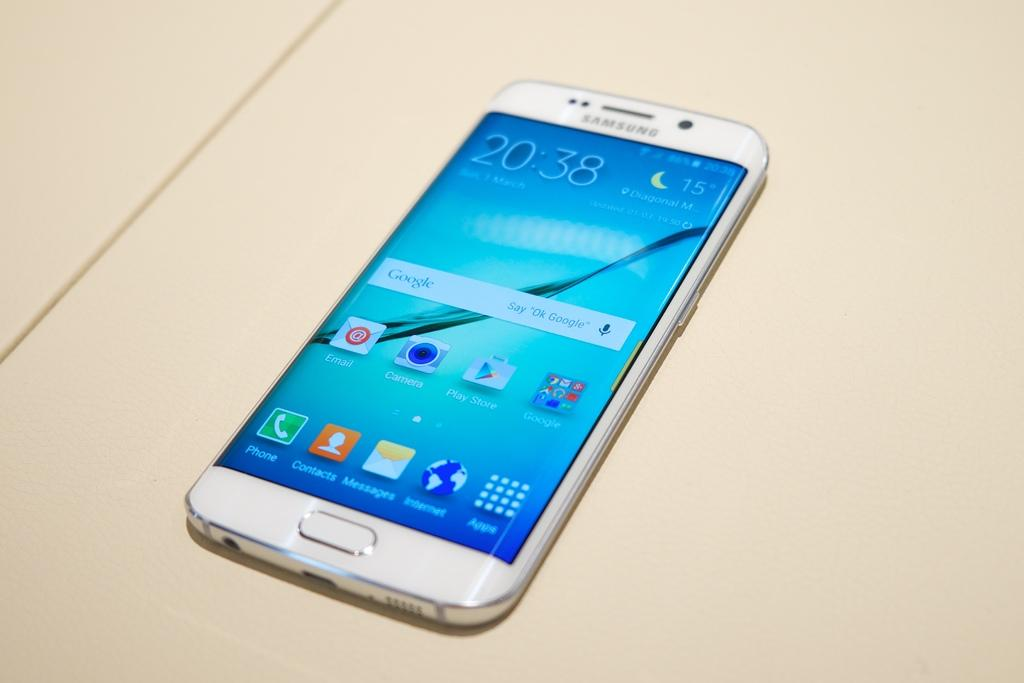<image>
Relay a brief, clear account of the picture shown. a phone that reads 20:38 on the front 